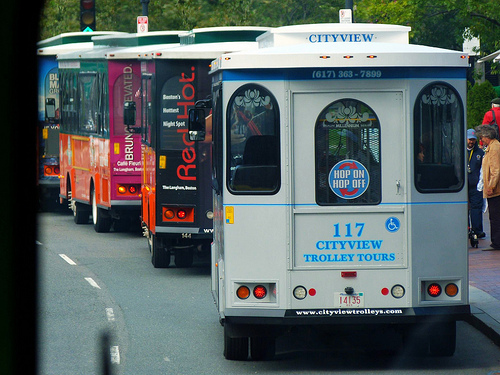<image>
Is there a tire under the window? Yes. The tire is positioned underneath the window, with the window above it in the vertical space. 